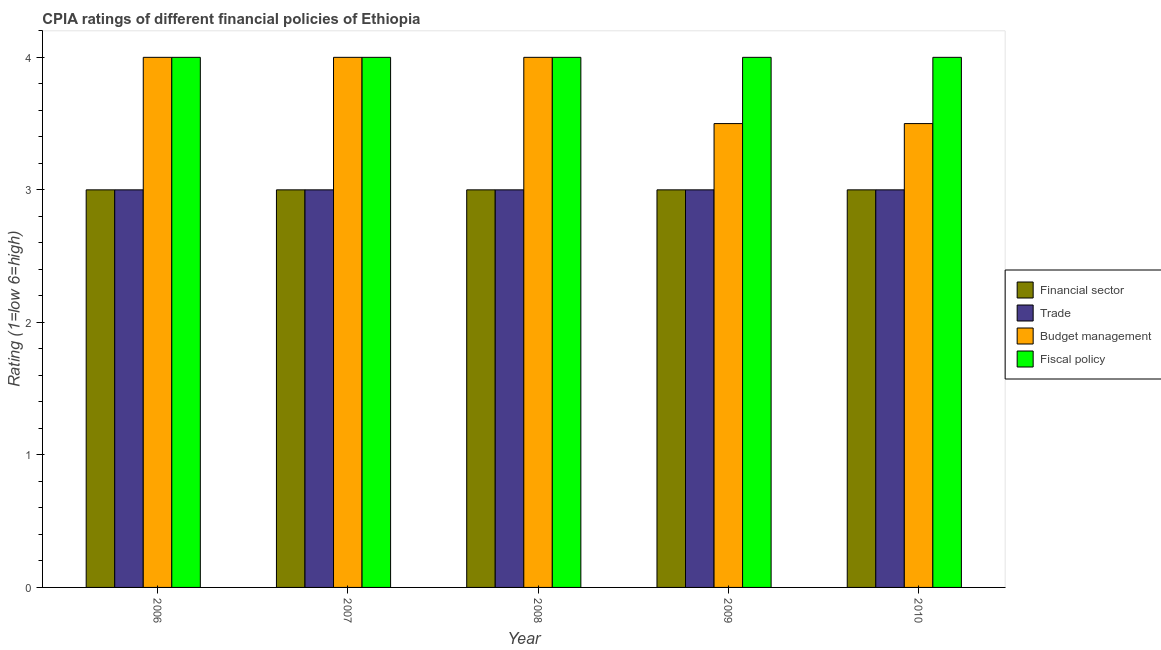How many different coloured bars are there?
Offer a terse response. 4. Are the number of bars per tick equal to the number of legend labels?
Your response must be concise. Yes. Are the number of bars on each tick of the X-axis equal?
Ensure brevity in your answer.  Yes. In how many cases, is the number of bars for a given year not equal to the number of legend labels?
Your answer should be very brief. 0. What is the cpia rating of financial sector in 2008?
Keep it short and to the point. 3. Across all years, what is the maximum cpia rating of trade?
Give a very brief answer. 3. Across all years, what is the minimum cpia rating of budget management?
Your response must be concise. 3.5. In which year was the cpia rating of fiscal policy maximum?
Keep it short and to the point. 2006. What is the total cpia rating of financial sector in the graph?
Provide a short and direct response. 15. What is the difference between the cpia rating of financial sector in 2006 and that in 2008?
Offer a terse response. 0. What is the difference between the cpia rating of financial sector in 2010 and the cpia rating of trade in 2009?
Provide a short and direct response. 0. What is the difference between the highest and the second highest cpia rating of financial sector?
Your answer should be compact. 0. What does the 2nd bar from the left in 2010 represents?
Your answer should be very brief. Trade. What does the 2nd bar from the right in 2007 represents?
Offer a very short reply. Budget management. Is it the case that in every year, the sum of the cpia rating of financial sector and cpia rating of trade is greater than the cpia rating of budget management?
Provide a short and direct response. Yes. What is the difference between two consecutive major ticks on the Y-axis?
Provide a succinct answer. 1. Are the values on the major ticks of Y-axis written in scientific E-notation?
Give a very brief answer. No. Where does the legend appear in the graph?
Keep it short and to the point. Center right. How are the legend labels stacked?
Your response must be concise. Vertical. What is the title of the graph?
Your answer should be very brief. CPIA ratings of different financial policies of Ethiopia. What is the label or title of the Y-axis?
Your answer should be compact. Rating (1=low 6=high). What is the Rating (1=low 6=high) of Financial sector in 2006?
Make the answer very short. 3. What is the Rating (1=low 6=high) in Trade in 2006?
Ensure brevity in your answer.  3. What is the Rating (1=low 6=high) in Budget management in 2006?
Provide a succinct answer. 4. What is the Rating (1=low 6=high) of Financial sector in 2007?
Offer a very short reply. 3. What is the Rating (1=low 6=high) in Budget management in 2007?
Give a very brief answer. 4. What is the Rating (1=low 6=high) in Fiscal policy in 2007?
Provide a short and direct response. 4. What is the Rating (1=low 6=high) of Financial sector in 2008?
Offer a terse response. 3. What is the Rating (1=low 6=high) of Trade in 2008?
Provide a succinct answer. 3. What is the Rating (1=low 6=high) of Financial sector in 2009?
Your response must be concise. 3. What is the Rating (1=low 6=high) in Budget management in 2009?
Give a very brief answer. 3.5. What is the Rating (1=low 6=high) in Fiscal policy in 2009?
Keep it short and to the point. 4. What is the Rating (1=low 6=high) in Financial sector in 2010?
Offer a very short reply. 3. Across all years, what is the maximum Rating (1=low 6=high) of Trade?
Your answer should be very brief. 3. Across all years, what is the maximum Rating (1=low 6=high) in Fiscal policy?
Your response must be concise. 4. Across all years, what is the minimum Rating (1=low 6=high) of Financial sector?
Make the answer very short. 3. Across all years, what is the minimum Rating (1=low 6=high) of Trade?
Provide a succinct answer. 3. Across all years, what is the minimum Rating (1=low 6=high) of Budget management?
Give a very brief answer. 3.5. What is the total Rating (1=low 6=high) of Financial sector in the graph?
Offer a terse response. 15. What is the total Rating (1=low 6=high) of Trade in the graph?
Keep it short and to the point. 15. What is the difference between the Rating (1=low 6=high) of Trade in 2006 and that in 2007?
Your response must be concise. 0. What is the difference between the Rating (1=low 6=high) in Budget management in 2006 and that in 2007?
Give a very brief answer. 0. What is the difference between the Rating (1=low 6=high) in Fiscal policy in 2006 and that in 2007?
Your answer should be compact. 0. What is the difference between the Rating (1=low 6=high) in Financial sector in 2006 and that in 2008?
Provide a succinct answer. 0. What is the difference between the Rating (1=low 6=high) in Trade in 2006 and that in 2008?
Give a very brief answer. 0. What is the difference between the Rating (1=low 6=high) of Budget management in 2006 and that in 2008?
Provide a succinct answer. 0. What is the difference between the Rating (1=low 6=high) of Fiscal policy in 2006 and that in 2008?
Your answer should be compact. 0. What is the difference between the Rating (1=low 6=high) of Financial sector in 2006 and that in 2009?
Keep it short and to the point. 0. What is the difference between the Rating (1=low 6=high) in Financial sector in 2006 and that in 2010?
Provide a short and direct response. 0. What is the difference between the Rating (1=low 6=high) in Budget management in 2006 and that in 2010?
Provide a succinct answer. 0.5. What is the difference between the Rating (1=low 6=high) of Fiscal policy in 2006 and that in 2010?
Your answer should be very brief. 0. What is the difference between the Rating (1=low 6=high) in Trade in 2007 and that in 2008?
Offer a terse response. 0. What is the difference between the Rating (1=low 6=high) of Budget management in 2007 and that in 2008?
Your answer should be compact. 0. What is the difference between the Rating (1=low 6=high) in Financial sector in 2007 and that in 2010?
Provide a short and direct response. 0. What is the difference between the Rating (1=low 6=high) in Trade in 2008 and that in 2009?
Provide a succinct answer. 0. What is the difference between the Rating (1=low 6=high) in Fiscal policy in 2008 and that in 2009?
Provide a succinct answer. 0. What is the difference between the Rating (1=low 6=high) of Trade in 2008 and that in 2010?
Keep it short and to the point. 0. What is the difference between the Rating (1=low 6=high) in Trade in 2009 and that in 2010?
Your answer should be very brief. 0. What is the difference between the Rating (1=low 6=high) of Fiscal policy in 2009 and that in 2010?
Offer a terse response. 0. What is the difference between the Rating (1=low 6=high) of Financial sector in 2006 and the Rating (1=low 6=high) of Trade in 2007?
Your answer should be compact. 0. What is the difference between the Rating (1=low 6=high) in Financial sector in 2006 and the Rating (1=low 6=high) in Budget management in 2007?
Make the answer very short. -1. What is the difference between the Rating (1=low 6=high) of Trade in 2006 and the Rating (1=low 6=high) of Budget management in 2007?
Provide a succinct answer. -1. What is the difference between the Rating (1=low 6=high) in Trade in 2006 and the Rating (1=low 6=high) in Budget management in 2008?
Provide a succinct answer. -1. What is the difference between the Rating (1=low 6=high) in Financial sector in 2006 and the Rating (1=low 6=high) in Trade in 2009?
Your answer should be very brief. 0. What is the difference between the Rating (1=low 6=high) in Budget management in 2006 and the Rating (1=low 6=high) in Fiscal policy in 2009?
Offer a very short reply. 0. What is the difference between the Rating (1=low 6=high) of Financial sector in 2006 and the Rating (1=low 6=high) of Trade in 2010?
Provide a succinct answer. 0. What is the difference between the Rating (1=low 6=high) of Financial sector in 2006 and the Rating (1=low 6=high) of Budget management in 2010?
Keep it short and to the point. -0.5. What is the difference between the Rating (1=low 6=high) of Financial sector in 2006 and the Rating (1=low 6=high) of Fiscal policy in 2010?
Provide a succinct answer. -1. What is the difference between the Rating (1=low 6=high) of Trade in 2006 and the Rating (1=low 6=high) of Budget management in 2010?
Keep it short and to the point. -0.5. What is the difference between the Rating (1=low 6=high) in Financial sector in 2007 and the Rating (1=low 6=high) in Trade in 2008?
Your answer should be compact. 0. What is the difference between the Rating (1=low 6=high) in Financial sector in 2007 and the Rating (1=low 6=high) in Budget management in 2008?
Keep it short and to the point. -1. What is the difference between the Rating (1=low 6=high) of Financial sector in 2007 and the Rating (1=low 6=high) of Budget management in 2009?
Keep it short and to the point. -0.5. What is the difference between the Rating (1=low 6=high) of Financial sector in 2007 and the Rating (1=low 6=high) of Fiscal policy in 2009?
Your answer should be compact. -1. What is the difference between the Rating (1=low 6=high) in Trade in 2007 and the Rating (1=low 6=high) in Budget management in 2009?
Your answer should be very brief. -0.5. What is the difference between the Rating (1=low 6=high) in Budget management in 2007 and the Rating (1=low 6=high) in Fiscal policy in 2009?
Give a very brief answer. 0. What is the difference between the Rating (1=low 6=high) of Trade in 2007 and the Rating (1=low 6=high) of Budget management in 2010?
Offer a terse response. -0.5. What is the difference between the Rating (1=low 6=high) of Trade in 2007 and the Rating (1=low 6=high) of Fiscal policy in 2010?
Offer a very short reply. -1. What is the difference between the Rating (1=low 6=high) of Budget management in 2007 and the Rating (1=low 6=high) of Fiscal policy in 2010?
Your answer should be compact. 0. What is the difference between the Rating (1=low 6=high) of Financial sector in 2008 and the Rating (1=low 6=high) of Budget management in 2009?
Provide a succinct answer. -0.5. What is the difference between the Rating (1=low 6=high) of Trade in 2008 and the Rating (1=low 6=high) of Fiscal policy in 2009?
Provide a succinct answer. -1. What is the difference between the Rating (1=low 6=high) in Financial sector in 2008 and the Rating (1=low 6=high) in Trade in 2010?
Offer a terse response. 0. What is the difference between the Rating (1=low 6=high) in Financial sector in 2008 and the Rating (1=low 6=high) in Budget management in 2010?
Give a very brief answer. -0.5. What is the difference between the Rating (1=low 6=high) of Financial sector in 2008 and the Rating (1=low 6=high) of Fiscal policy in 2010?
Ensure brevity in your answer.  -1. What is the average Rating (1=low 6=high) of Financial sector per year?
Your answer should be compact. 3. What is the average Rating (1=low 6=high) of Budget management per year?
Make the answer very short. 3.8. What is the average Rating (1=low 6=high) of Fiscal policy per year?
Ensure brevity in your answer.  4. In the year 2006, what is the difference between the Rating (1=low 6=high) of Financial sector and Rating (1=low 6=high) of Trade?
Keep it short and to the point. 0. In the year 2006, what is the difference between the Rating (1=low 6=high) of Financial sector and Rating (1=low 6=high) of Budget management?
Offer a terse response. -1. In the year 2006, what is the difference between the Rating (1=low 6=high) of Trade and Rating (1=low 6=high) of Budget management?
Provide a short and direct response. -1. In the year 2006, what is the difference between the Rating (1=low 6=high) of Budget management and Rating (1=low 6=high) of Fiscal policy?
Ensure brevity in your answer.  0. In the year 2007, what is the difference between the Rating (1=low 6=high) in Financial sector and Rating (1=low 6=high) in Trade?
Ensure brevity in your answer.  0. In the year 2007, what is the difference between the Rating (1=low 6=high) in Financial sector and Rating (1=low 6=high) in Budget management?
Offer a terse response. -1. In the year 2007, what is the difference between the Rating (1=low 6=high) in Budget management and Rating (1=low 6=high) in Fiscal policy?
Provide a short and direct response. 0. In the year 2009, what is the difference between the Rating (1=low 6=high) in Trade and Rating (1=low 6=high) in Budget management?
Keep it short and to the point. -0.5. In the year 2009, what is the difference between the Rating (1=low 6=high) of Trade and Rating (1=low 6=high) of Fiscal policy?
Your answer should be compact. -1. In the year 2010, what is the difference between the Rating (1=low 6=high) of Trade and Rating (1=low 6=high) of Budget management?
Keep it short and to the point. -0.5. In the year 2010, what is the difference between the Rating (1=low 6=high) in Trade and Rating (1=low 6=high) in Fiscal policy?
Offer a terse response. -1. In the year 2010, what is the difference between the Rating (1=low 6=high) in Budget management and Rating (1=low 6=high) in Fiscal policy?
Offer a very short reply. -0.5. What is the ratio of the Rating (1=low 6=high) in Financial sector in 2006 to that in 2007?
Ensure brevity in your answer.  1. What is the ratio of the Rating (1=low 6=high) of Trade in 2006 to that in 2007?
Provide a succinct answer. 1. What is the ratio of the Rating (1=low 6=high) of Budget management in 2006 to that in 2007?
Offer a very short reply. 1. What is the ratio of the Rating (1=low 6=high) in Fiscal policy in 2006 to that in 2007?
Your answer should be compact. 1. What is the ratio of the Rating (1=low 6=high) of Financial sector in 2006 to that in 2008?
Your answer should be very brief. 1. What is the ratio of the Rating (1=low 6=high) of Trade in 2006 to that in 2008?
Your answer should be very brief. 1. What is the ratio of the Rating (1=low 6=high) of Budget management in 2006 to that in 2008?
Provide a succinct answer. 1. What is the ratio of the Rating (1=low 6=high) of Fiscal policy in 2006 to that in 2008?
Your response must be concise. 1. What is the ratio of the Rating (1=low 6=high) of Financial sector in 2006 to that in 2009?
Offer a very short reply. 1. What is the ratio of the Rating (1=low 6=high) in Budget management in 2006 to that in 2009?
Make the answer very short. 1.14. What is the ratio of the Rating (1=low 6=high) in Fiscal policy in 2006 to that in 2009?
Offer a very short reply. 1. What is the ratio of the Rating (1=low 6=high) in Financial sector in 2006 to that in 2010?
Keep it short and to the point. 1. What is the ratio of the Rating (1=low 6=high) of Trade in 2006 to that in 2010?
Your answer should be compact. 1. What is the ratio of the Rating (1=low 6=high) of Trade in 2007 to that in 2008?
Offer a terse response. 1. What is the ratio of the Rating (1=low 6=high) in Fiscal policy in 2007 to that in 2008?
Keep it short and to the point. 1. What is the ratio of the Rating (1=low 6=high) of Budget management in 2007 to that in 2009?
Your response must be concise. 1.14. What is the ratio of the Rating (1=low 6=high) in Fiscal policy in 2007 to that in 2009?
Keep it short and to the point. 1. What is the ratio of the Rating (1=low 6=high) of Financial sector in 2007 to that in 2010?
Give a very brief answer. 1. What is the ratio of the Rating (1=low 6=high) in Budget management in 2007 to that in 2010?
Your response must be concise. 1.14. What is the ratio of the Rating (1=low 6=high) of Fiscal policy in 2007 to that in 2010?
Provide a succinct answer. 1. What is the ratio of the Rating (1=low 6=high) of Trade in 2008 to that in 2009?
Ensure brevity in your answer.  1. What is the ratio of the Rating (1=low 6=high) of Budget management in 2008 to that in 2010?
Offer a terse response. 1.14. What is the ratio of the Rating (1=low 6=high) of Fiscal policy in 2008 to that in 2010?
Give a very brief answer. 1. What is the ratio of the Rating (1=low 6=high) of Budget management in 2009 to that in 2010?
Your answer should be very brief. 1. What is the ratio of the Rating (1=low 6=high) of Fiscal policy in 2009 to that in 2010?
Provide a succinct answer. 1. What is the difference between the highest and the second highest Rating (1=low 6=high) in Financial sector?
Offer a terse response. 0. What is the difference between the highest and the second highest Rating (1=low 6=high) of Trade?
Offer a terse response. 0. What is the difference between the highest and the second highest Rating (1=low 6=high) of Budget management?
Your response must be concise. 0. What is the difference between the highest and the lowest Rating (1=low 6=high) of Trade?
Your answer should be very brief. 0. 